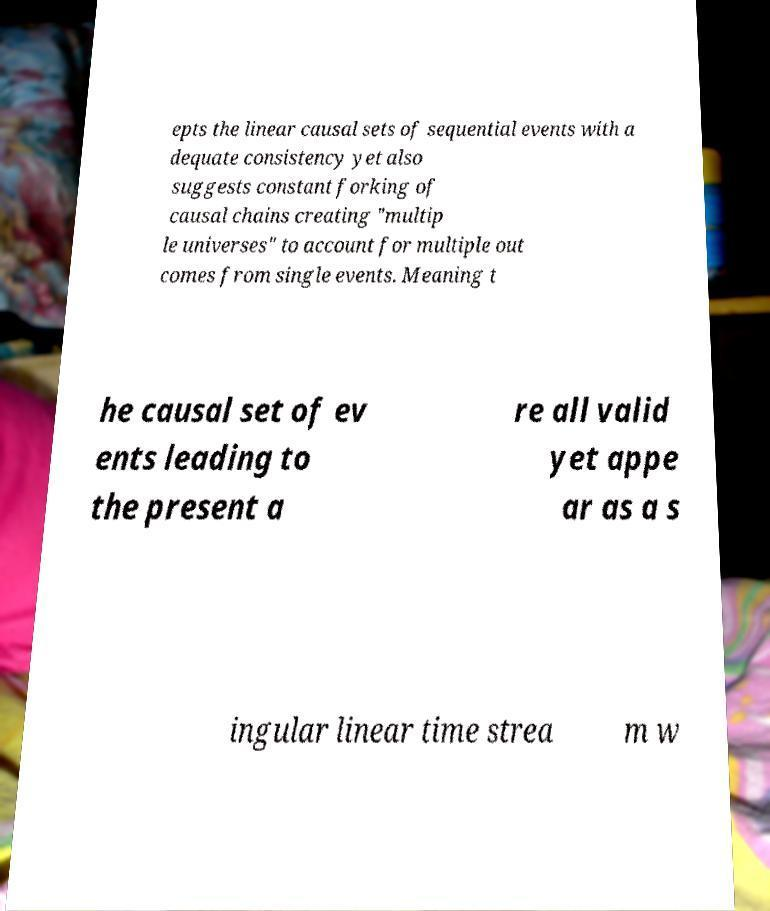Can you accurately transcribe the text from the provided image for me? epts the linear causal sets of sequential events with a dequate consistency yet also suggests constant forking of causal chains creating "multip le universes" to account for multiple out comes from single events. Meaning t he causal set of ev ents leading to the present a re all valid yet appe ar as a s ingular linear time strea m w 